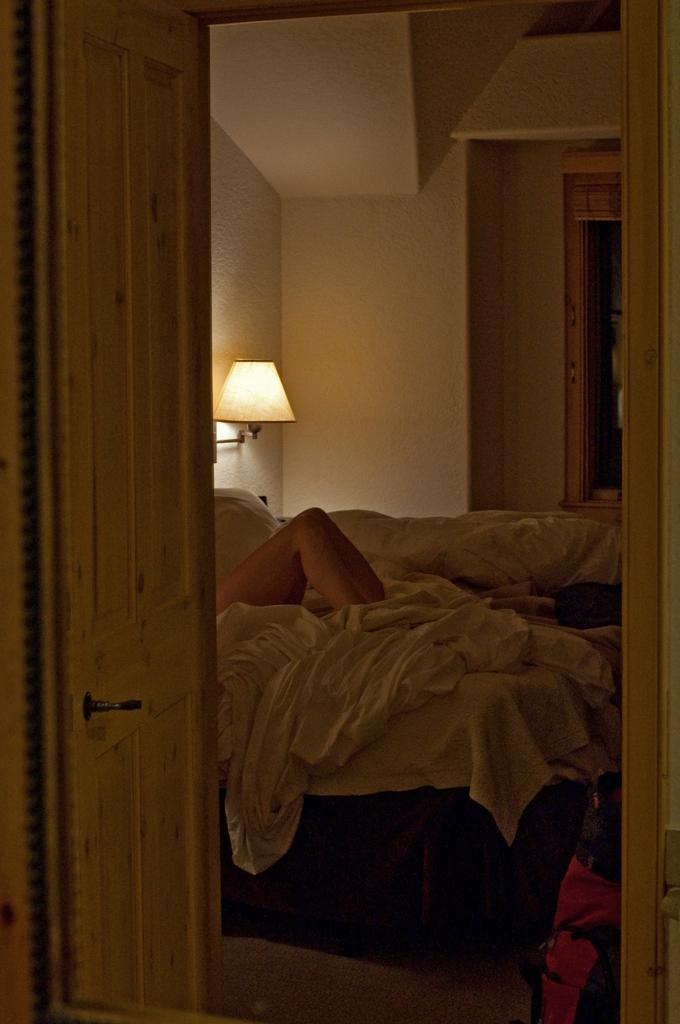What is one of the main features of the image? There is a door in the image. What can be seen in relation to the bed in the image? A person's legs are visible on a bed. What type of bedding is present in the image? There are blankets in the image. What provides illumination in the image? There is a light in the image. Can you describe any other objects in the image? There are a few unspecified objects in the image. What type of calculator is being used by the person on the bed in the image? There is no calculator visible in the image; only a person's legs on a bed are shown. 